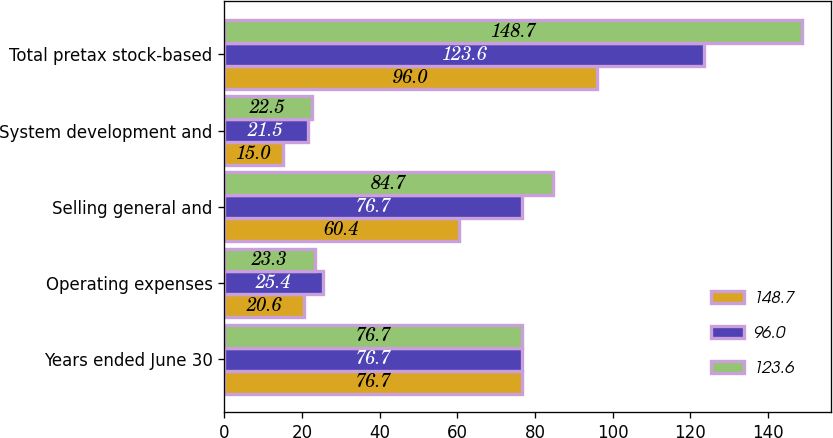Convert chart to OTSL. <chart><loc_0><loc_0><loc_500><loc_500><stacked_bar_chart><ecel><fcel>Years ended June 30<fcel>Operating expenses<fcel>Selling general and<fcel>System development and<fcel>Total pretax stock-based<nl><fcel>148.7<fcel>76.7<fcel>20.6<fcel>60.4<fcel>15<fcel>96<nl><fcel>96<fcel>76.7<fcel>25.4<fcel>76.7<fcel>21.5<fcel>123.6<nl><fcel>123.6<fcel>76.7<fcel>23.3<fcel>84.7<fcel>22.5<fcel>148.7<nl></chart> 